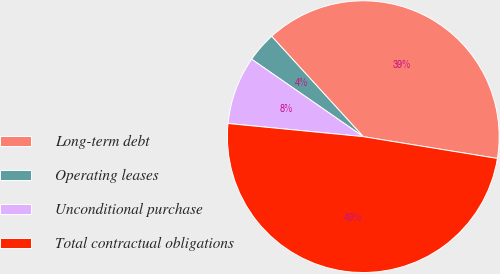Convert chart to OTSL. <chart><loc_0><loc_0><loc_500><loc_500><pie_chart><fcel>Long-term debt<fcel>Operating leases<fcel>Unconditional purchase<fcel>Total contractual obligations<nl><fcel>39.34%<fcel>3.57%<fcel>8.11%<fcel>48.98%<nl></chart> 